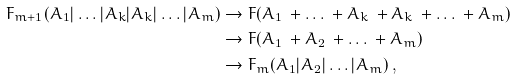Convert formula to latex. <formula><loc_0><loc_0><loc_500><loc_500>F _ { m + 1 } ( A _ { 1 } | \dots | A _ { k } | A _ { k } | \dots | A _ { m } ) & \to F ( A _ { 1 } \ + \dots \ + A _ { k } \ + A _ { k } \ + \dots \ + A _ { m } ) \\ & \to F ( A _ { 1 } \ + A _ { 2 } \ + \dots \ + A _ { m } ) \\ & \to F _ { m } ( A _ { 1 } | A _ { 2 } | \dots | A _ { m } ) \, ,</formula> 